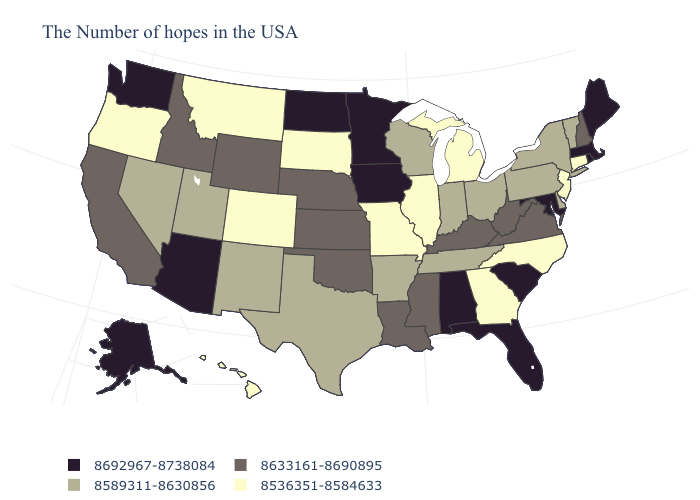Does North Carolina have the lowest value in the South?
Concise answer only. Yes. Name the states that have a value in the range 8692967-8738084?
Write a very short answer. Maine, Massachusetts, Rhode Island, Maryland, South Carolina, Florida, Alabama, Minnesota, Iowa, North Dakota, Arizona, Washington, Alaska. Does Wyoming have the highest value in the West?
Answer briefly. No. What is the value of Oklahoma?
Write a very short answer. 8633161-8690895. What is the value of Washington?
Write a very short answer. 8692967-8738084. Name the states that have a value in the range 8589311-8630856?
Quick response, please. Vermont, New York, Delaware, Pennsylvania, Ohio, Indiana, Tennessee, Wisconsin, Arkansas, Texas, New Mexico, Utah, Nevada. Name the states that have a value in the range 8633161-8690895?
Quick response, please. New Hampshire, Virginia, West Virginia, Kentucky, Mississippi, Louisiana, Kansas, Nebraska, Oklahoma, Wyoming, Idaho, California. What is the value of North Dakota?
Answer briefly. 8692967-8738084. Among the states that border Rhode Island , which have the lowest value?
Write a very short answer. Connecticut. Which states have the highest value in the USA?
Give a very brief answer. Maine, Massachusetts, Rhode Island, Maryland, South Carolina, Florida, Alabama, Minnesota, Iowa, North Dakota, Arizona, Washington, Alaska. What is the value of Idaho?
Give a very brief answer. 8633161-8690895. Name the states that have a value in the range 8589311-8630856?
Short answer required. Vermont, New York, Delaware, Pennsylvania, Ohio, Indiana, Tennessee, Wisconsin, Arkansas, Texas, New Mexico, Utah, Nevada. Name the states that have a value in the range 8589311-8630856?
Be succinct. Vermont, New York, Delaware, Pennsylvania, Ohio, Indiana, Tennessee, Wisconsin, Arkansas, Texas, New Mexico, Utah, Nevada. Does the first symbol in the legend represent the smallest category?
Be succinct. No. What is the value of New Hampshire?
Short answer required. 8633161-8690895. 